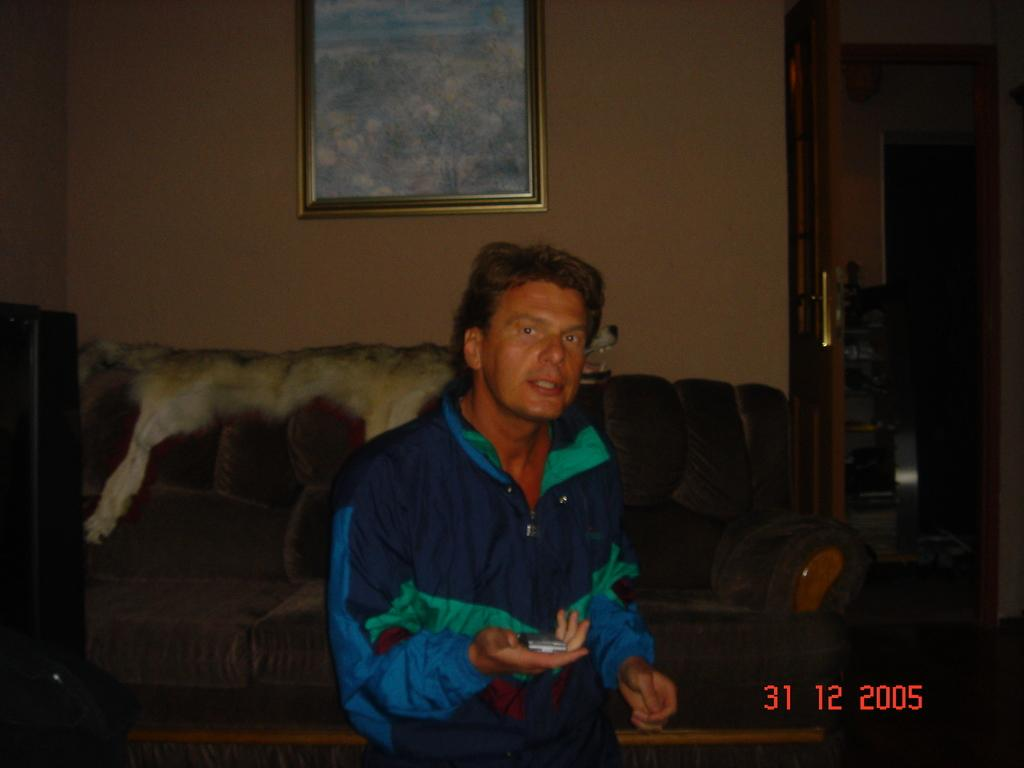What is the main subject of the image? There is a person in the image. What is the person holding in the image? The person is holding an object. What can be seen in the background of the image? There is a sofa and a photo frame attached to the wall in the background of the image. What type of tramp can be seen in the image? There is no tramp present in the image. Can you hear the bell ringing in the image? There is no bell present in the image, so it cannot be heard. 